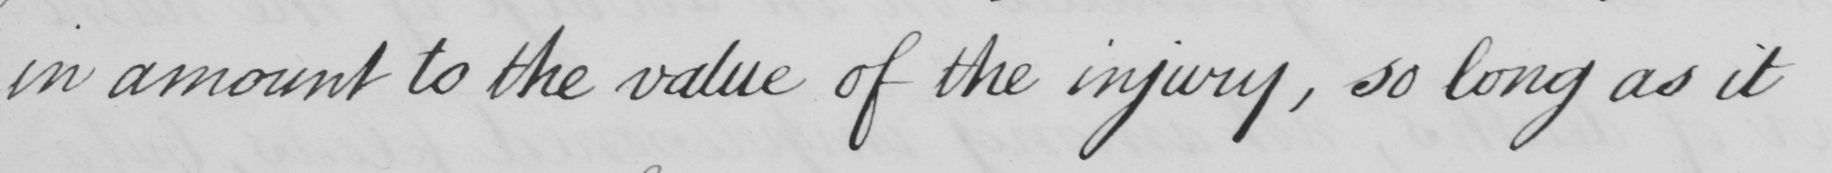Can you tell me what this handwritten text says? in amount to the value of the injury , so long as it 